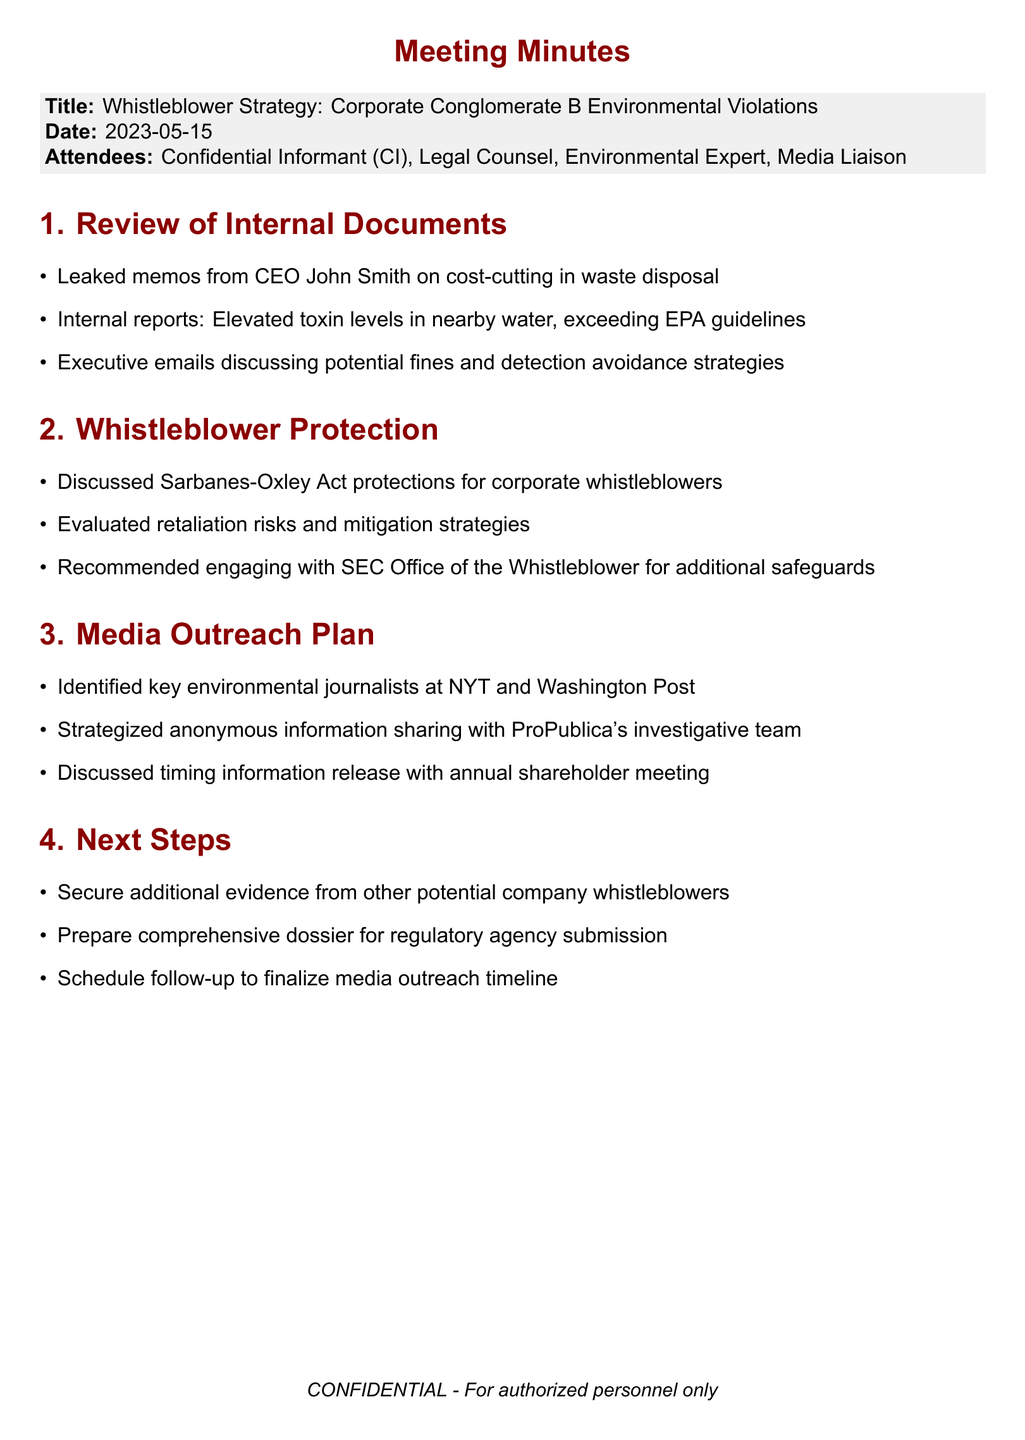What is the meeting title? The meeting title can be found in the header of the document, which states "Whistleblower Strategy: Corporate Conglomerate B Environmental Violations."
Answer: Whistleblower Strategy: Corporate Conglomerate B Environmental Violations Who is the CEO mentioned in the leaked memos? The CEO is referenced in the context of leaked memos as John Smith.
Answer: John Smith What act was discussed regarding whistleblower protections? The Sarbanes-Oxley Act is specified in the document as a reference for corporate whistleblower protections.
Answer: Sarbanes-Oxley Act Which two major newspapers' journalists were identified for media outreach? The document lists The New York Times and The Washington Post as the key environmental journalists targeted for outreach.
Answer: The New York Times and The Washington Post What is one strategy mentioned for sharing information anonymously? The strategy involves sharing information with ProPublica's investigative team, as outlined in the media outreach plan.
Answer: ProPublica's investigative team How many agenda items are listed in the document? The document contains four distinct agenda items listed under main sections.
Answer: 4 What is the date of the meeting? The date of the meeting is stated clearly in the header as May 15, 2023.
Answer: 2023-05-15 What is the first action item listed under Next Steps? The first action item is to secure additional corroborating evidence from other potential whistleblowers within the company.
Answer: Secure additional corroborating evidence from other potential whistleblowers within the company What does the document state will be scheduled after the meeting? The follow-up meeting is to be scheduled to finalize the media outreach timeline.
Answer: Schedule follow-up meeting to finalize media outreach timeline 